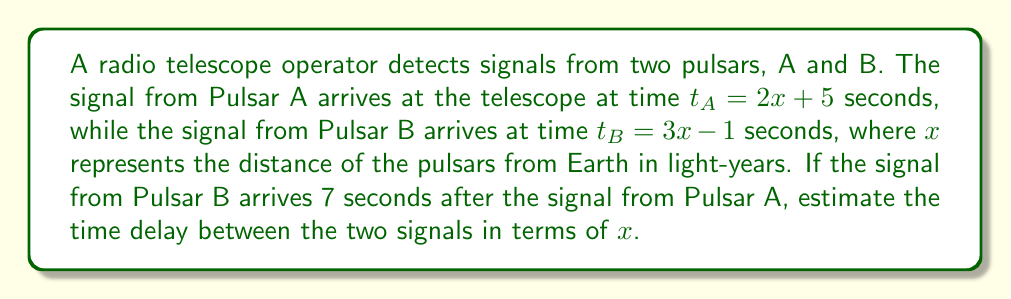What is the answer to this math problem? To solve this problem, we'll follow these steps:

1) We're given two linear equations for the arrival times of the signals:
   $t_A = 2x + 5$
   $t_B = 3x - 1$

2) We're told that the signal from Pulsar B arrives 7 seconds after the signal from Pulsar A. We can express this as:
   $t_B = t_A + 7$

3) Substituting the equations from step 1 into the equation from step 2:
   $3x - 1 = (2x + 5) + 7$

4) Simplify the right side of the equation:
   $3x - 1 = 2x + 12$

5) Subtract $2x$ from both sides:
   $x - 1 = 12$

6) Add 1 to both sides:
   $x = 13$

7) Now that we know the value of $x$, we can calculate $t_A$ and $t_B$:
   $t_A = 2(13) + 5 = 31$
   $t_B = 3(13) - 1 = 38$

8) The time delay is the difference between $t_B$ and $t_A$:
   Time delay = $t_B - t_A = 38 - 31 = 7$ seconds

9) To express this in terms of $x$, we can subtract the original equations:
   Time delay = $t_B - t_A = (3x - 1) - (2x + 5) = x - 6$

Therefore, the time delay between the two signals can be expressed as $x - 6$ seconds.
Answer: $x - 6$ seconds 